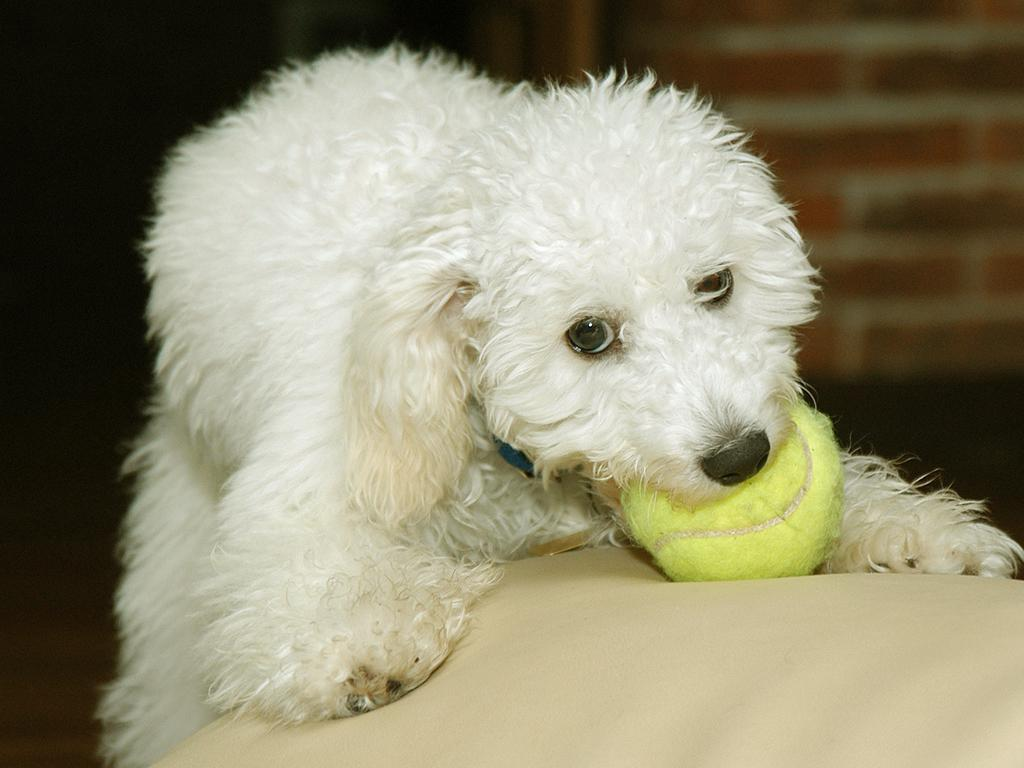What animal can be seen in the image? There is a dog in the image. What is the dog holding in its mouth? The dog is holding a ball in its mouth. What position is the dog in? The dog is laying on a surface. How is the background of the image depicted? The background of the dog is blurred. What type of stamp can be seen on the dog's collar in the image? There is no stamp visible on the dog's collar in the image. Can you see a net being used to catch the dog in the image? There is no net present in the image, and the dog is not being caught. 